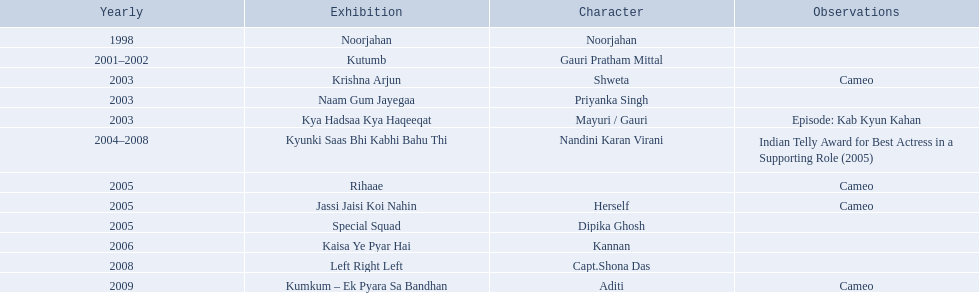What shows did gauri pradhan tejwani star in? Noorjahan, Kutumb, Krishna Arjun, Naam Gum Jayegaa, Kya Hadsaa Kya Haqeeqat, Kyunki Saas Bhi Kabhi Bahu Thi, Rihaae, Jassi Jaisi Koi Nahin, Special Squad, Kaisa Ye Pyar Hai, Left Right Left, Kumkum – Ek Pyara Sa Bandhan. Of these, which were cameos? Krishna Arjun, Rihaae, Jassi Jaisi Koi Nahin, Kumkum – Ek Pyara Sa Bandhan. Of these, in which did she play the role of herself? Jassi Jaisi Koi Nahin. 